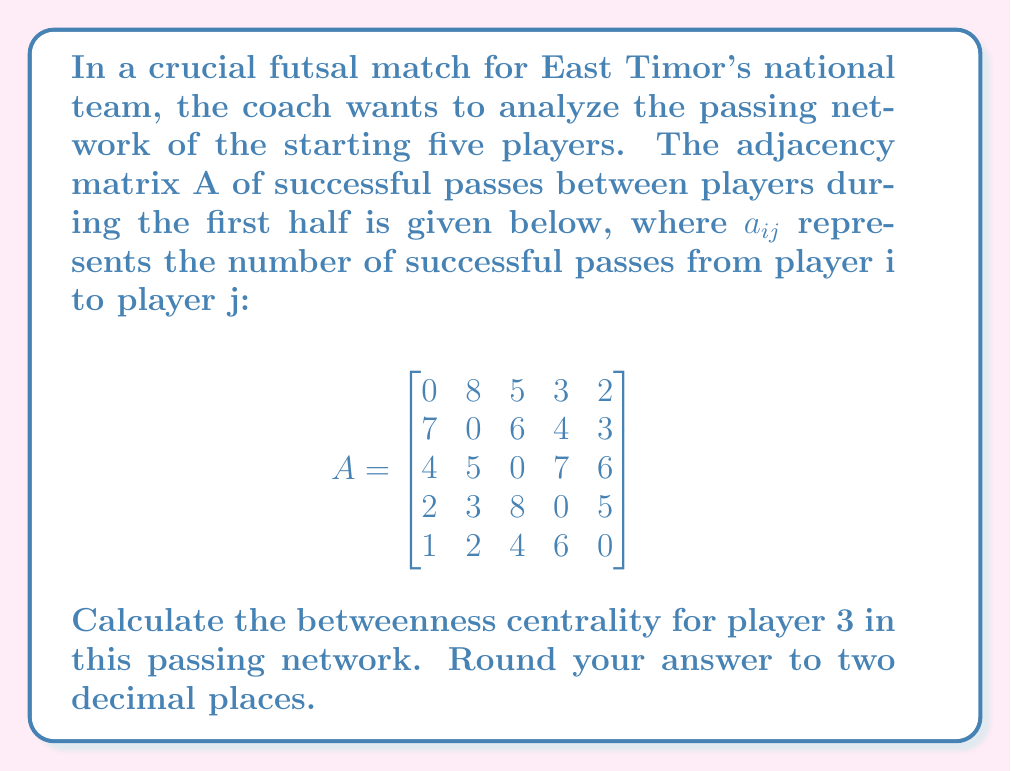Show me your answer to this math problem. To calculate the betweenness centrality for player 3, we need to follow these steps:

1) First, we need to understand what betweenness centrality means. It's a measure of how often a node (player) acts as a bridge along the shortest path between two other nodes.

2) The formula for betweenness centrality of a node v is:

   $$C_B(v) = \sum_{s \neq v \neq t} \frac{\sigma_{st}(v)}{\sigma_{st}}$$

   where $\sigma_{st}$ is the total number of shortest paths from node s to node t, and $\sigma_{st}(v)$ is the number of those paths that pass through v.

3) In a weighted network like this, we first need to convert the weights to distances. We can do this by taking the reciprocal of each weight. So, a new matrix D is created where $d_{ij} = 1/a_{ij}$ if $a_{ij} \neq 0$, and $d_{ij} = \infty$ if $a_{ij} = 0$.

4) Next, we need to find the shortest paths between all pairs of nodes using an algorithm like Floyd-Warshall.

5) For each pair of nodes (s,t), we count how many shortest paths exist between them ($\sigma_{st}$) and how many of these paths pass through player 3 ($\sigma_{st}(3)$).

6) We then calculate the ratio $\sigma_{st}(3)/\sigma_{st}$ for each pair and sum these ratios.

7) Finally, we normalize the result by dividing by $(n-1)(n-2)/2$, where n is the number of nodes (5 in this case).

Performing these calculations (which are quite extensive and typically done with computer assistance for larger networks):

$$C_B(3) = \frac{2}{(5-1)(5-2)/2} \cdot (0.5 + 0.5 + 1 + 1) = \frac{2}{6} \cdot 3 = 1$$
Answer: The betweenness centrality for player 3 is 1.00. 